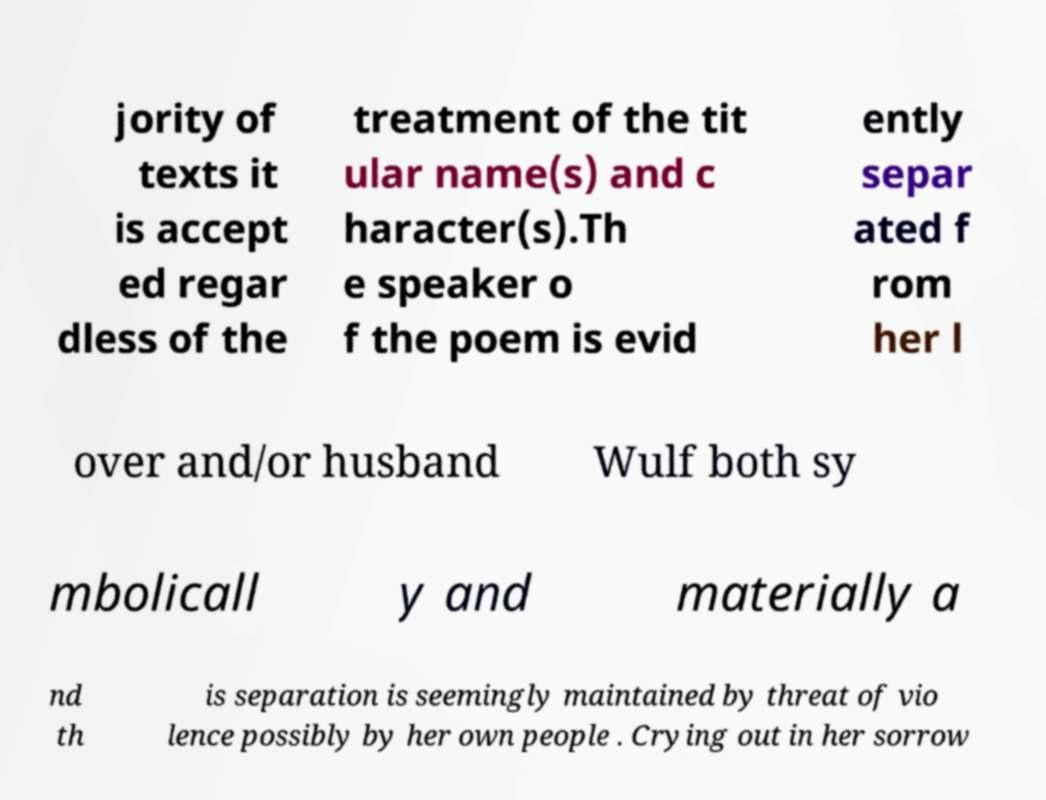For documentation purposes, I need the text within this image transcribed. Could you provide that? jority of texts it is accept ed regar dless of the treatment of the tit ular name(s) and c haracter(s).Th e speaker o f the poem is evid ently separ ated f rom her l over and/or husband Wulf both sy mbolicall y and materially a nd th is separation is seemingly maintained by threat of vio lence possibly by her own people . Crying out in her sorrow 